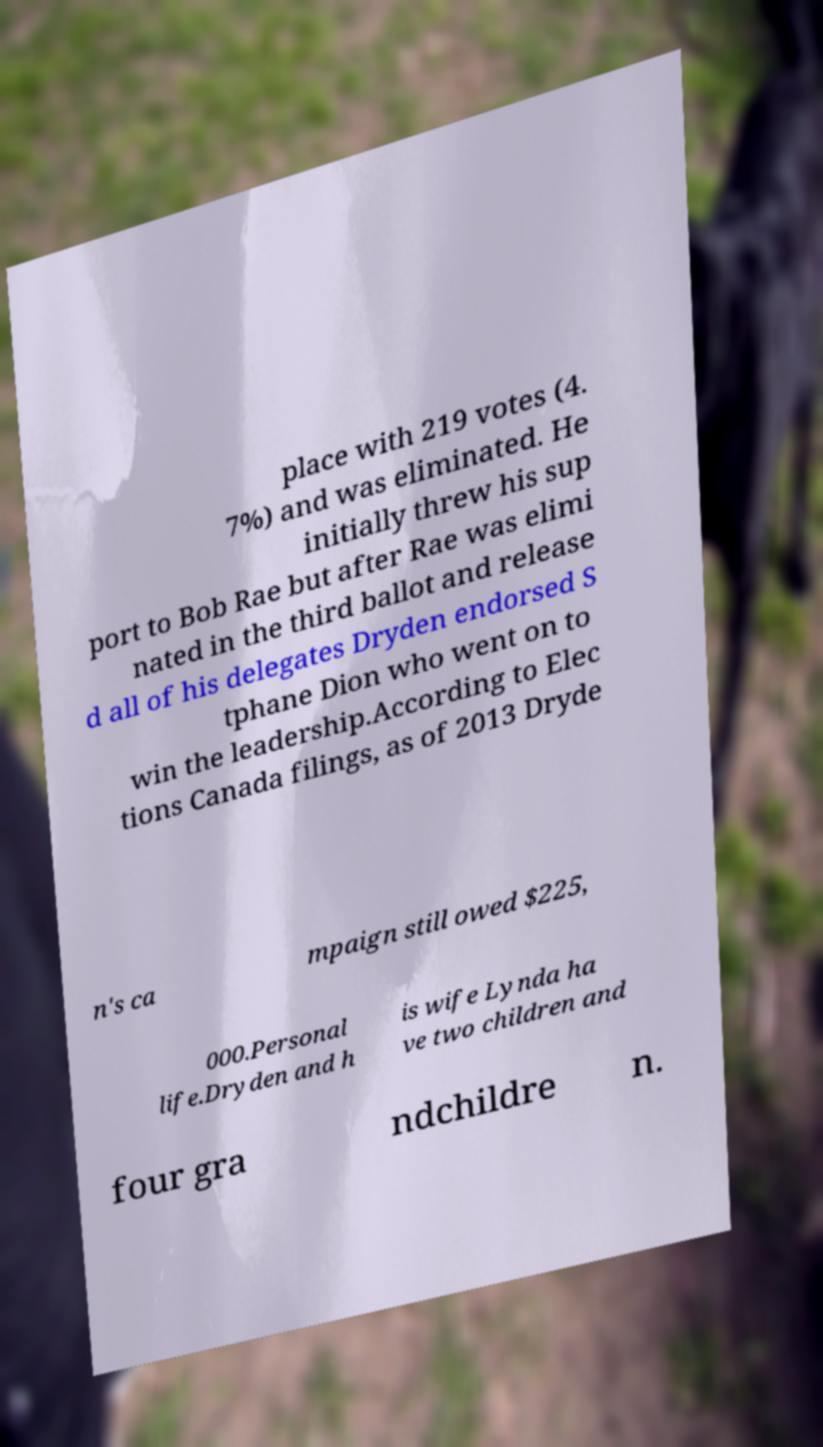What messages or text are displayed in this image? I need them in a readable, typed format. place with 219 votes (4. 7%) and was eliminated. He initially threw his sup port to Bob Rae but after Rae was elimi nated in the third ballot and release d all of his delegates Dryden endorsed S tphane Dion who went on to win the leadership.According to Elec tions Canada filings, as of 2013 Dryde n's ca mpaign still owed $225, 000.Personal life.Dryden and h is wife Lynda ha ve two children and four gra ndchildre n. 